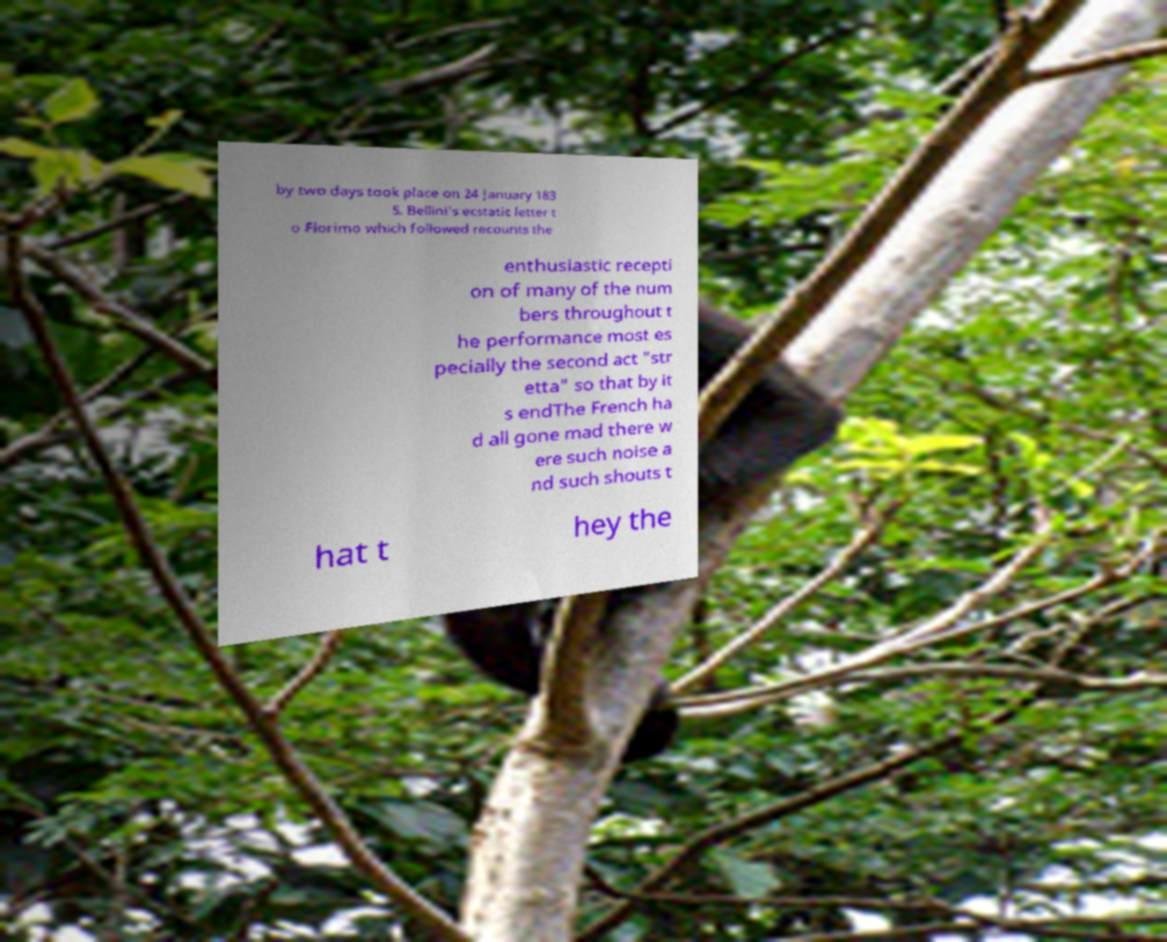Can you read and provide the text displayed in the image?This photo seems to have some interesting text. Can you extract and type it out for me? by two days took place on 24 January 183 5. Bellini's ecstatic letter t o Florimo which followed recounts the enthusiastic recepti on of many of the num bers throughout t he performance most es pecially the second act "str etta" so that by it s endThe French ha d all gone mad there w ere such noise a nd such shouts t hat t hey the 